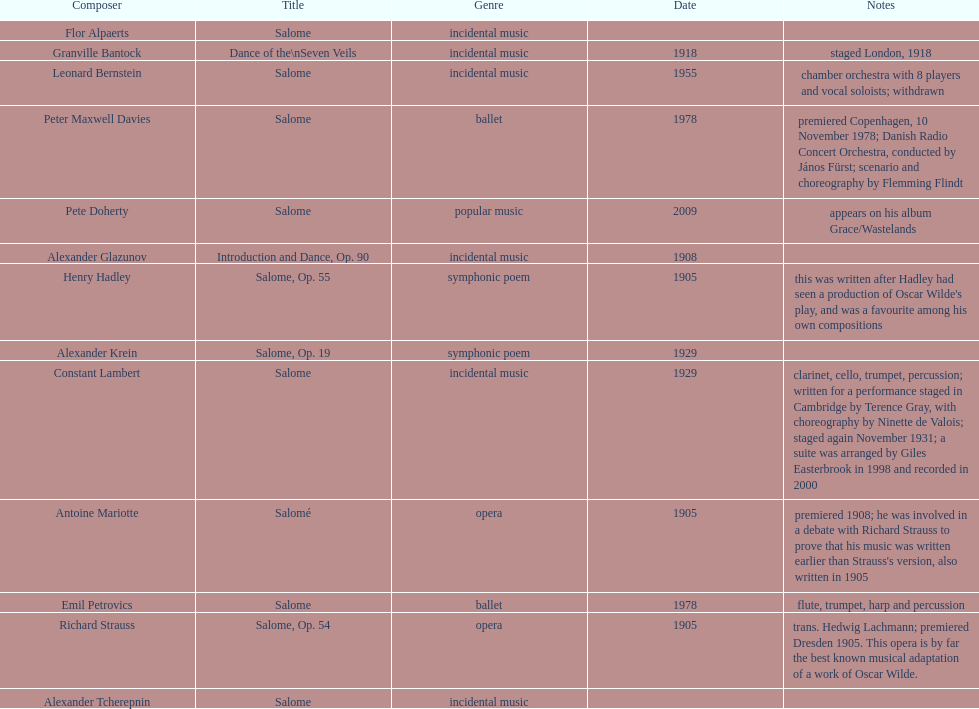How many works are titled "salome?" 11. 